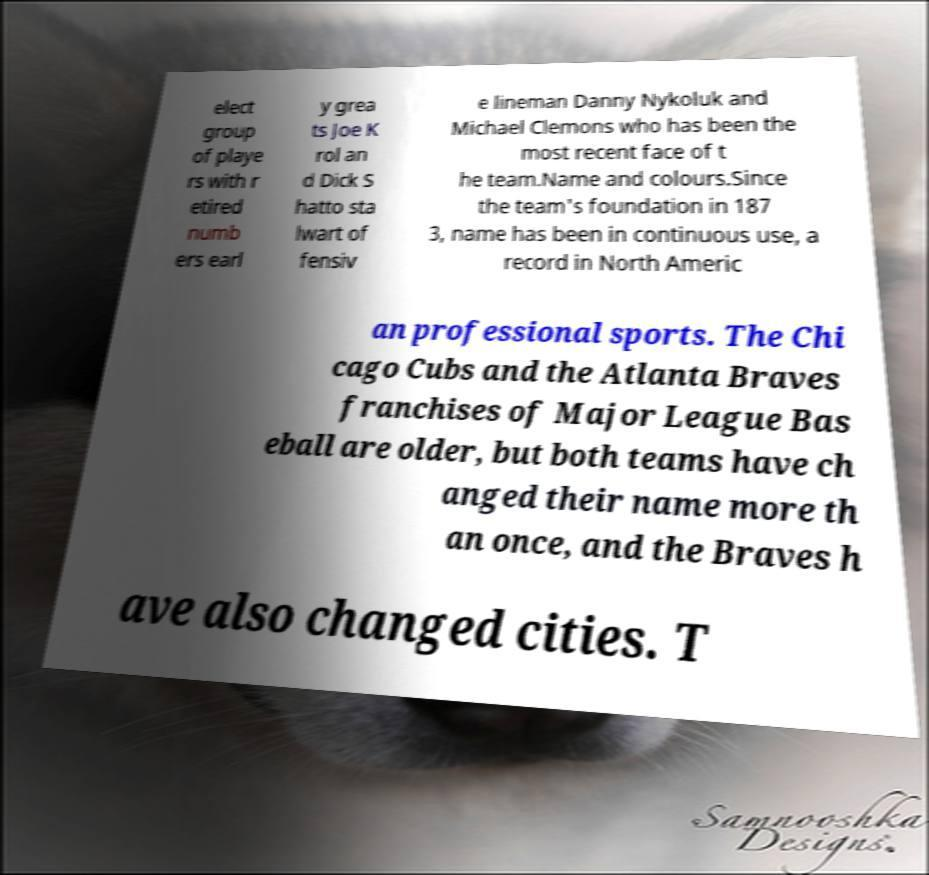Can you read and provide the text displayed in the image?This photo seems to have some interesting text. Can you extract and type it out for me? elect group of playe rs with r etired numb ers earl y grea ts Joe K rol an d Dick S hatto sta lwart of fensiv e lineman Danny Nykoluk and Michael Clemons who has been the most recent face of t he team.Name and colours.Since the team's foundation in 187 3, name has been in continuous use, a record in North Americ an professional sports. The Chi cago Cubs and the Atlanta Braves franchises of Major League Bas eball are older, but both teams have ch anged their name more th an once, and the Braves h ave also changed cities. T 